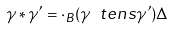Convert formula to latex. <formula><loc_0><loc_0><loc_500><loc_500>\gamma * \gamma ^ { \prime } = \cdot _ { B } ( \gamma \ t e n s \gamma ^ { \prime } ) \Delta</formula> 